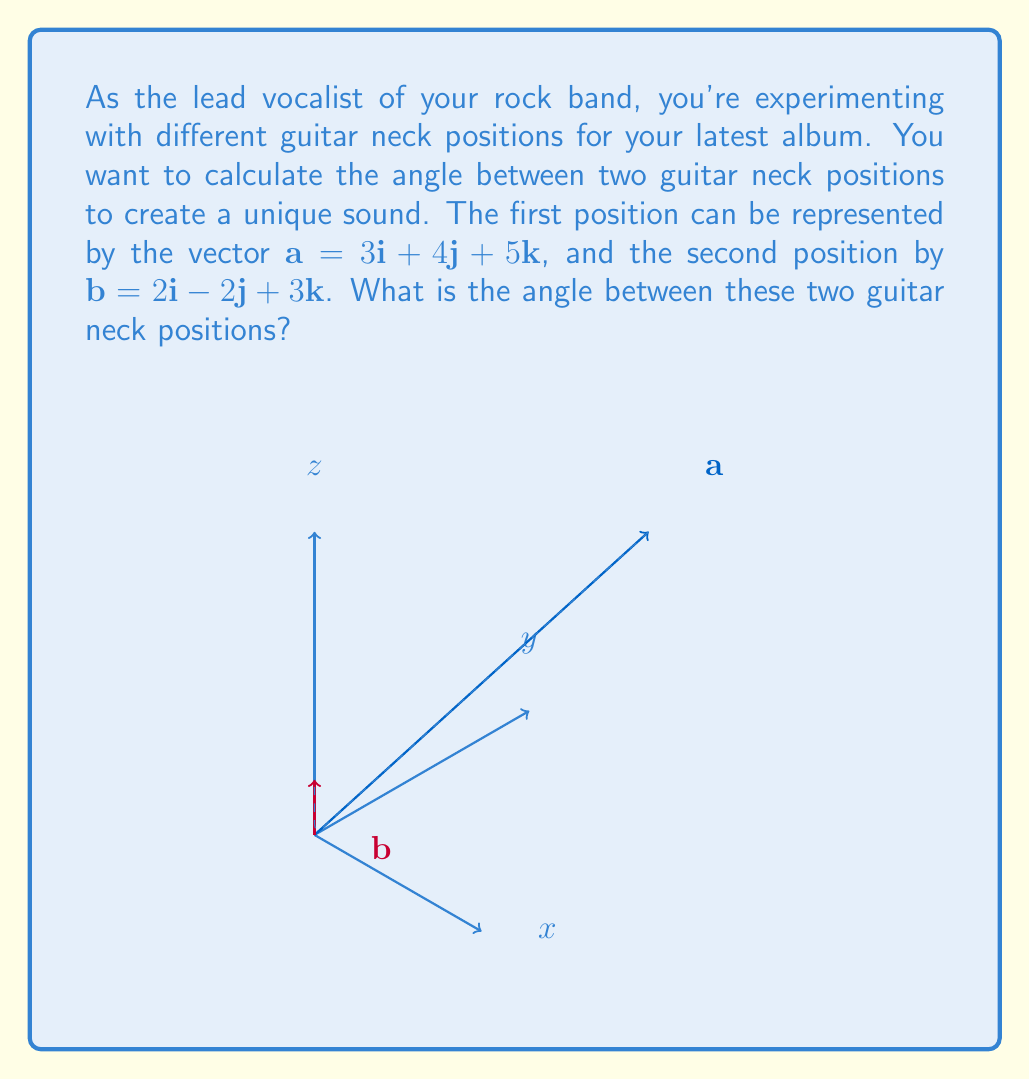Show me your answer to this math problem. To find the angle between two vectors, we can use the dot product formula:

$$\cos \theta = \frac{\mathbf{a} \cdot \mathbf{b}}{|\mathbf{a}||\mathbf{b}|}$$

Step 1: Calculate the dot product $\mathbf{a} \cdot \mathbf{b}$
$$\mathbf{a} \cdot \mathbf{b} = (3)(2) + (4)(-2) + (5)(3) = 6 - 8 + 15 = 13$$

Step 2: Calculate the magnitudes of $\mathbf{a}$ and $\mathbf{b}$
$$|\mathbf{a}| = \sqrt{3^2 + 4^2 + 5^2} = \sqrt{50}$$
$$|\mathbf{b}| = \sqrt{2^2 + (-2)^2 + 3^2} = \sqrt{17}$$

Step 3: Substitute into the formula
$$\cos \theta = \frac{13}{\sqrt{50}\sqrt{17}}$$

Step 4: Simplify
$$\cos \theta = \frac{13}{\sqrt{850}}$$

Step 5: Take the inverse cosine (arccos) of both sides
$$\theta = \arccos\left(\frac{13}{\sqrt{850}}\right)$$

Step 6: Calculate the result (in radians)
$$\theta \approx 0.8729 \text{ radians}$$

Step 7: Convert to degrees
$$\theta \approx 50.02°$$
Answer: $50.02°$ 